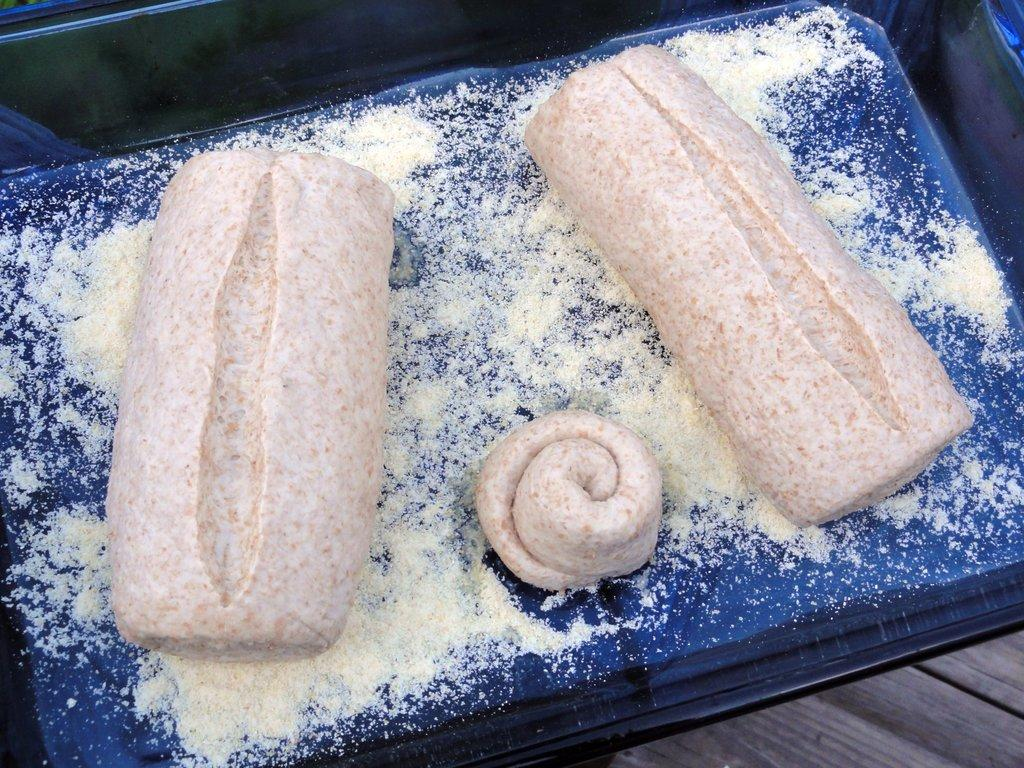What type of objects can be seen in the image? There are food items in the image. How are the food items arranged or contained? The food items are placed in a black color box. What type of finger can be seen in the image? There is no finger present in the image. What emotion is being expressed by the food items in the image? The food items do not express emotions, so it is not possible to determine if they are expressing anger or any other emotion. 